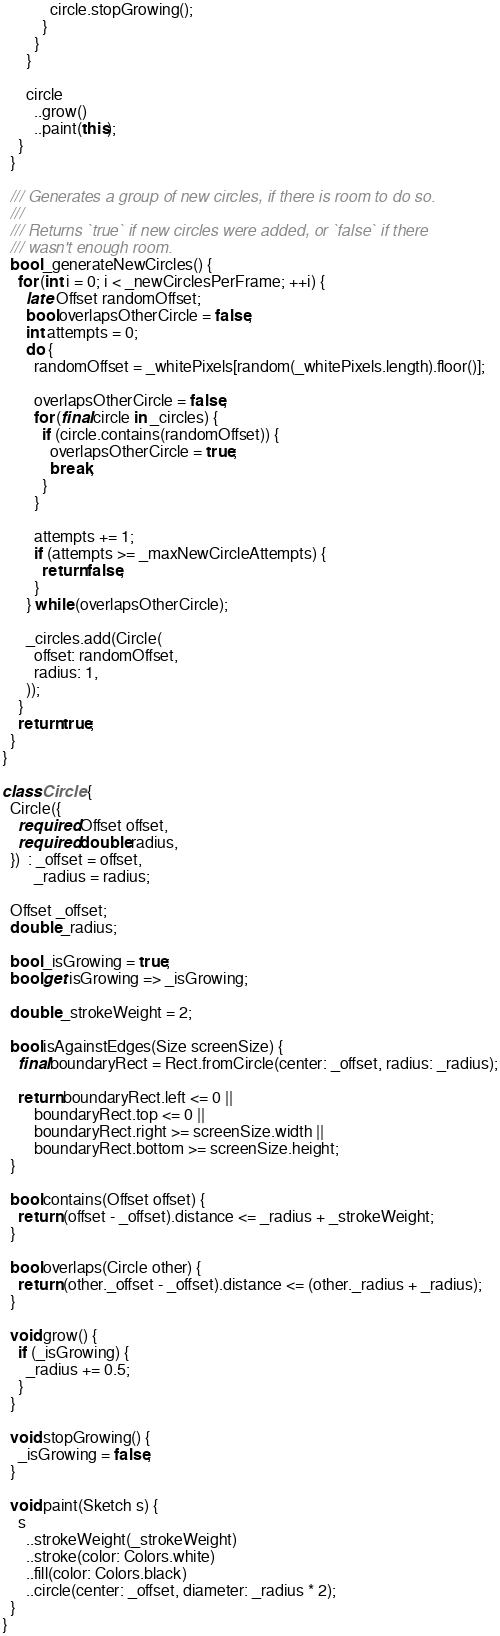<code> <loc_0><loc_0><loc_500><loc_500><_Dart_>            circle.stopGrowing();
          }
        }
      }

      circle
        ..grow()
        ..paint(this);
    }
  }

  /// Generates a group of new circles, if there is room to do so.
  ///
  /// Returns `true` if new circles were added, or `false` if there
  /// wasn't enough room.
  bool _generateNewCircles() {
    for (int i = 0; i < _newCirclesPerFrame; ++i) {
      late Offset randomOffset;
      bool overlapsOtherCircle = false;
      int attempts = 0;
      do {
        randomOffset = _whitePixels[random(_whitePixels.length).floor()];

        overlapsOtherCircle = false;
        for (final circle in _circles) {
          if (circle.contains(randomOffset)) {
            overlapsOtherCircle = true;
            break;
          }
        }

        attempts += 1;
        if (attempts >= _maxNewCircleAttempts) {
          return false;
        }
      } while (overlapsOtherCircle);

      _circles.add(Circle(
        offset: randomOffset,
        radius: 1,
      ));
    }
    return true;
  }
}

class Circle {
  Circle({
    required Offset offset,
    required double radius,
  })  : _offset = offset,
        _radius = radius;

  Offset _offset;
  double _radius;

  bool _isGrowing = true;
  bool get isGrowing => _isGrowing;

  double _strokeWeight = 2;

  bool isAgainstEdges(Size screenSize) {
    final boundaryRect = Rect.fromCircle(center: _offset, radius: _radius);

    return boundaryRect.left <= 0 ||
        boundaryRect.top <= 0 ||
        boundaryRect.right >= screenSize.width ||
        boundaryRect.bottom >= screenSize.height;
  }

  bool contains(Offset offset) {
    return (offset - _offset).distance <= _radius + _strokeWeight;
  }

  bool overlaps(Circle other) {
    return (other._offset - _offset).distance <= (other._radius + _radius);
  }

  void grow() {
    if (_isGrowing) {
      _radius += 0.5;
    }
  }

  void stopGrowing() {
    _isGrowing = false;
  }

  void paint(Sketch s) {
    s
      ..strokeWeight(_strokeWeight)
      ..stroke(color: Colors.white)
      ..fill(color: Colors.black)
      ..circle(center: _offset, diameter: _radius * 2);
  }
}
</code> 